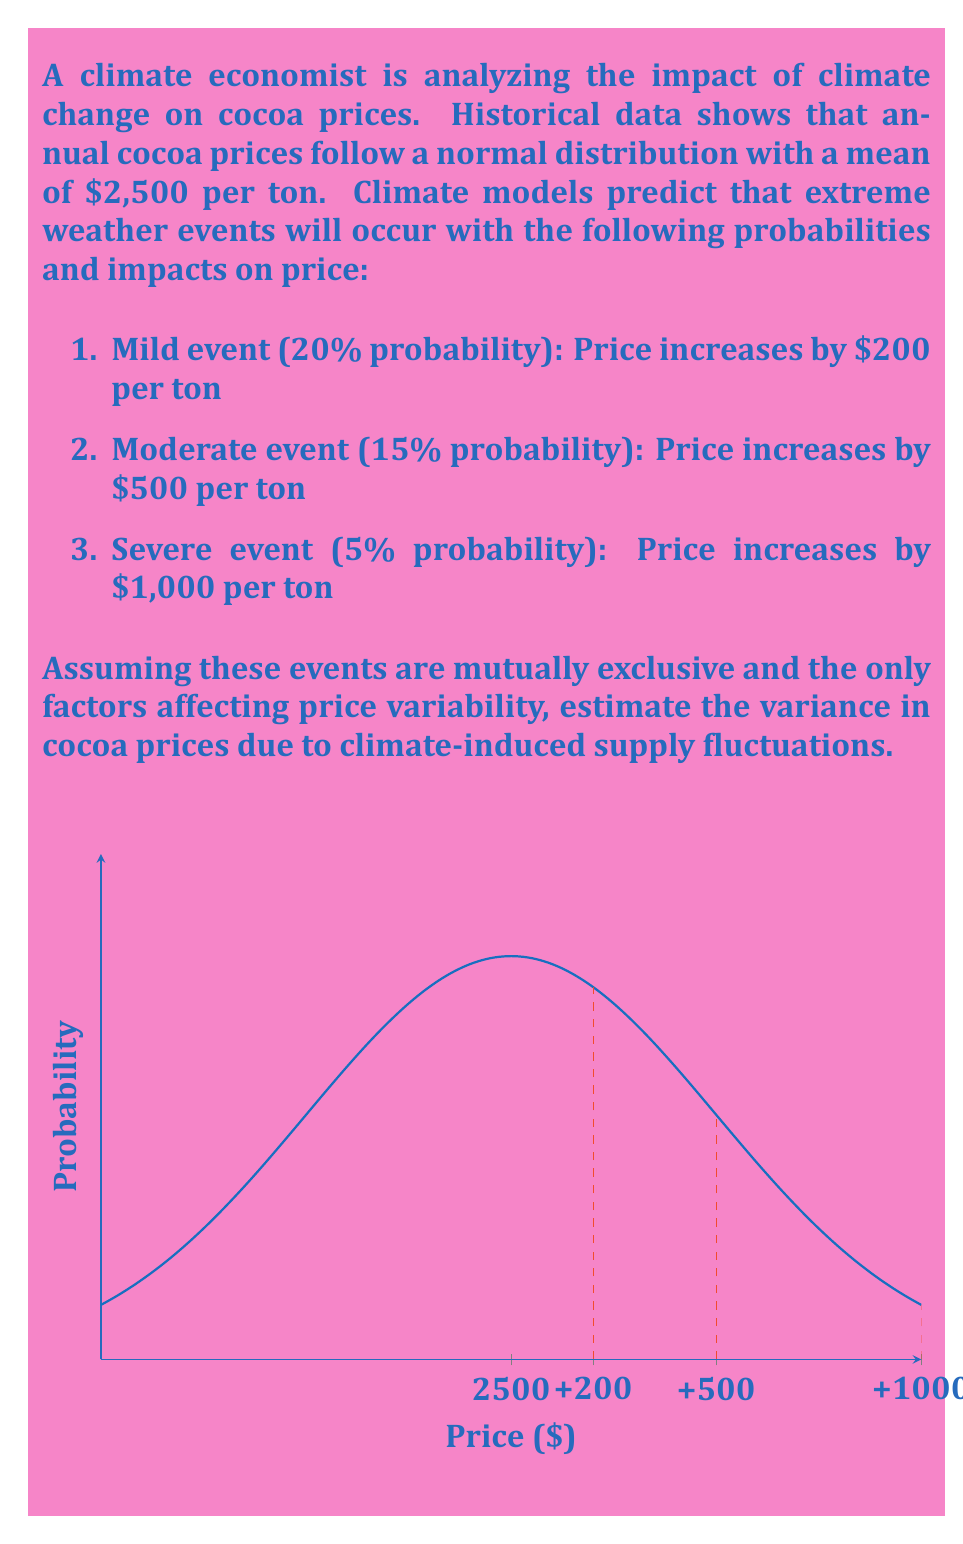Teach me how to tackle this problem. To estimate the variance, we'll use the formula for variance of a discrete random variable:

$$\text{Var}(X) = E(X^2) - [E(X)]^2$$

Where $E(X)$ is the expected value and $E(X^2)$ is the expected value of the squared random variable.

Step 1: Calculate the expected value E(X)

Let $X$ be the price increase due to climate events.

$$E(X) = 200 \cdot 0.20 + 500 \cdot 0.15 + 1000 \cdot 0.05 + 0 \cdot 0.60 = 145$$

The expected price increase is $145 per ton.

Step 2: Calculate E(X^2)

$$E(X^2) = 200^2 \cdot 0.20 + 500^2 \cdot 0.15 + 1000^2 \cdot 0.05 + 0^2 \cdot 0.60 = 95,000$$

Step 3: Calculate the variance

$$\text{Var}(X) = E(X^2) - [E(X)]^2 = 95,000 - 145^2 = 74,025$$

Therefore, the variance in cocoa prices due to climate-induced supply fluctuations is $74,025 ($/ton)^2$.
Answer: $74,025 ($/ton)^2$ 